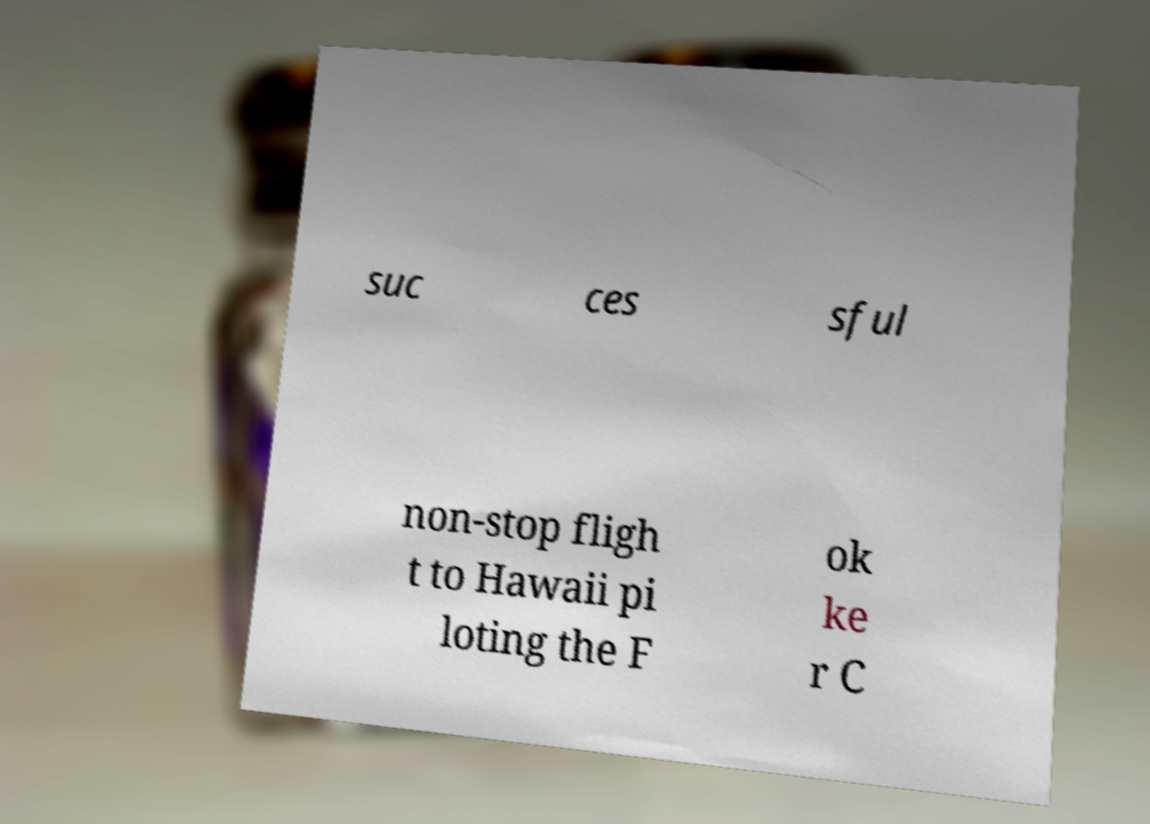Could you assist in decoding the text presented in this image and type it out clearly? suc ces sful non-stop fligh t to Hawaii pi loting the F ok ke r C 